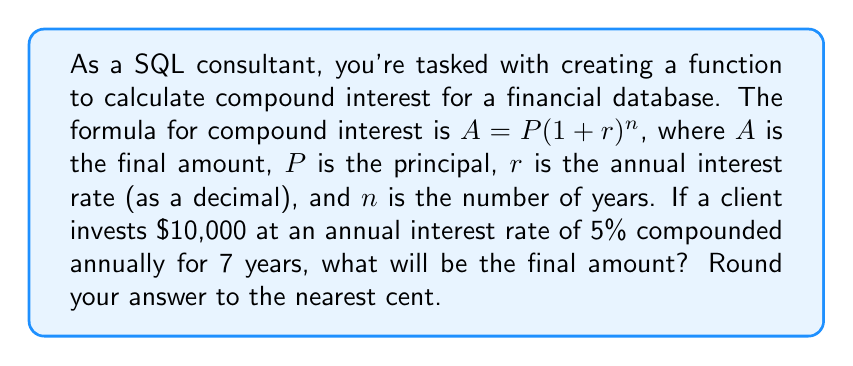What is the answer to this math problem? Let's break this down step-by-step:

1. Identify the given values:
   $P = 10,000$ (principal)
   $r = 0.05$ (5% annual interest rate as a decimal)
   $n = 7$ (number of years)

2. Plug these values into the compound interest formula:
   $A = P(1 + r)^n$
   $A = 10,000(1 + 0.05)^7$

3. Simplify the expression inside the parentheses:
   $A = 10,000(1.05)^7$

4. Calculate the exponent:
   $(1.05)^7 \approx 1.4071$

5. Multiply by the principal:
   $A = 10,000 \times 1.4071 = 14,071$

6. Round to the nearest cent:
   $A = 14,071.00$

In SQL, you could implement this calculation using the POWER function:
```sql
SELECT ROUND(10000 * POWER(1.05, 7), 2) AS final_amount;
```
Answer: $14,071.00 